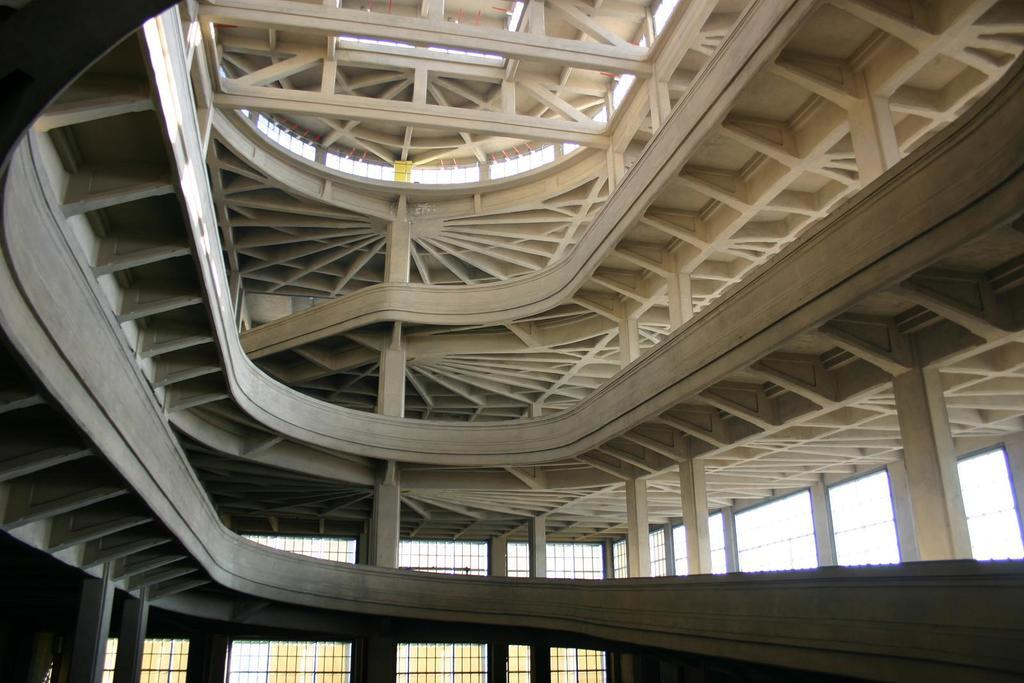What type of structure is present in the image? There is a building in the image. What feature of the building can be seen in the image? There are windows visible in the image. What can be seen in the background of the image? The sky is visible in the image. What type of lamp is used in the hospital depicted in the image? There is no hospital or lamp present in the image; it only features a building and the sky. What hobbies are the people in the image engaged in? There are no people present in the image, so their hobbies cannot be determined. 